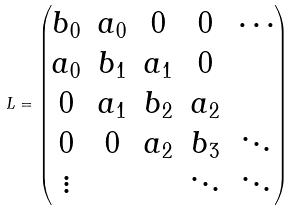<formula> <loc_0><loc_0><loc_500><loc_500>L = \left ( \begin{matrix} b _ { 0 } & a _ { 0 } & 0 & 0 & \cdots \\ a _ { 0 } & b _ { 1 } & a _ { 1 } & 0 \\ 0 & a _ { 1 } & b _ { 2 } & a _ { 2 } \\ 0 & 0 & a _ { 2 } & b _ { 3 } & \ddots \\ \vdots & & & \ddots & \ddots \end{matrix} \right )</formula> 